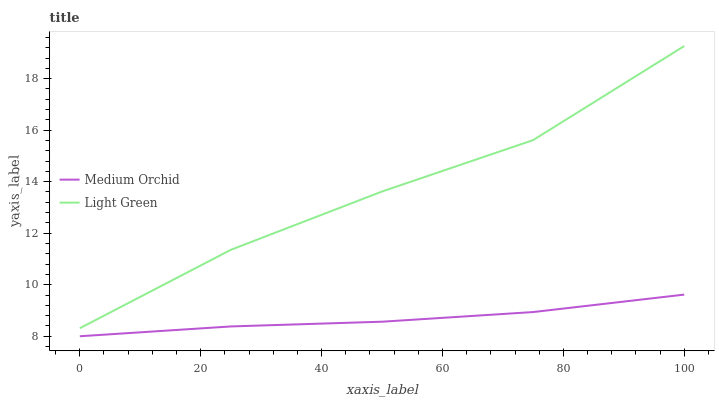Does Light Green have the minimum area under the curve?
Answer yes or no. No. Is Light Green the smoothest?
Answer yes or no. No. Does Light Green have the lowest value?
Answer yes or no. No. Is Medium Orchid less than Light Green?
Answer yes or no. Yes. Is Light Green greater than Medium Orchid?
Answer yes or no. Yes. Does Medium Orchid intersect Light Green?
Answer yes or no. No. 